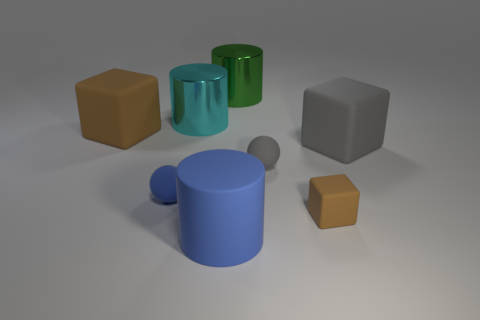There is a object that is the same color as the matte cylinder; what is its size?
Provide a succinct answer. Small. Is the color of the small block the same as the rubber cylinder?
Ensure brevity in your answer.  No. What is the shape of the big blue rubber object?
Your answer should be compact. Cylinder. Is there a big metallic cylinder of the same color as the rubber cylinder?
Offer a terse response. No. Is the number of matte cubes that are to the right of the small blue object greater than the number of big brown blocks?
Keep it short and to the point. Yes. Does the cyan metal object have the same shape as the brown matte thing behind the tiny gray ball?
Your answer should be very brief. No. Are there any large gray objects?
Provide a short and direct response. Yes. What number of big objects are either gray spheres or cyan metal cylinders?
Offer a terse response. 1. Are there more rubber objects on the left side of the gray block than blue balls that are behind the cyan shiny cylinder?
Your answer should be compact. Yes. Are the blue cylinder and the brown thing that is to the left of the cyan shiny cylinder made of the same material?
Your response must be concise. Yes. 